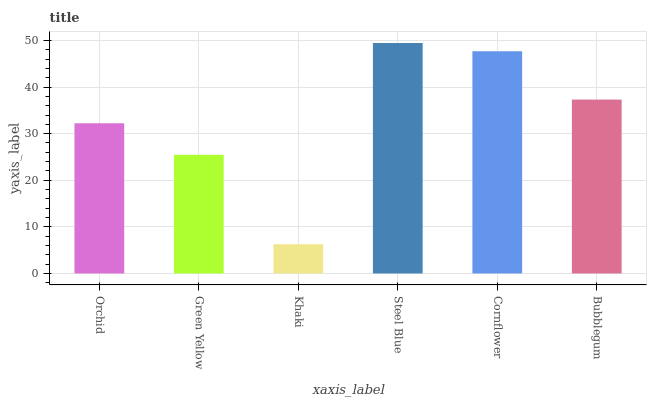Is Khaki the minimum?
Answer yes or no. Yes. Is Steel Blue the maximum?
Answer yes or no. Yes. Is Green Yellow the minimum?
Answer yes or no. No. Is Green Yellow the maximum?
Answer yes or no. No. Is Orchid greater than Green Yellow?
Answer yes or no. Yes. Is Green Yellow less than Orchid?
Answer yes or no. Yes. Is Green Yellow greater than Orchid?
Answer yes or no. No. Is Orchid less than Green Yellow?
Answer yes or no. No. Is Bubblegum the high median?
Answer yes or no. Yes. Is Orchid the low median?
Answer yes or no. Yes. Is Steel Blue the high median?
Answer yes or no. No. Is Cornflower the low median?
Answer yes or no. No. 